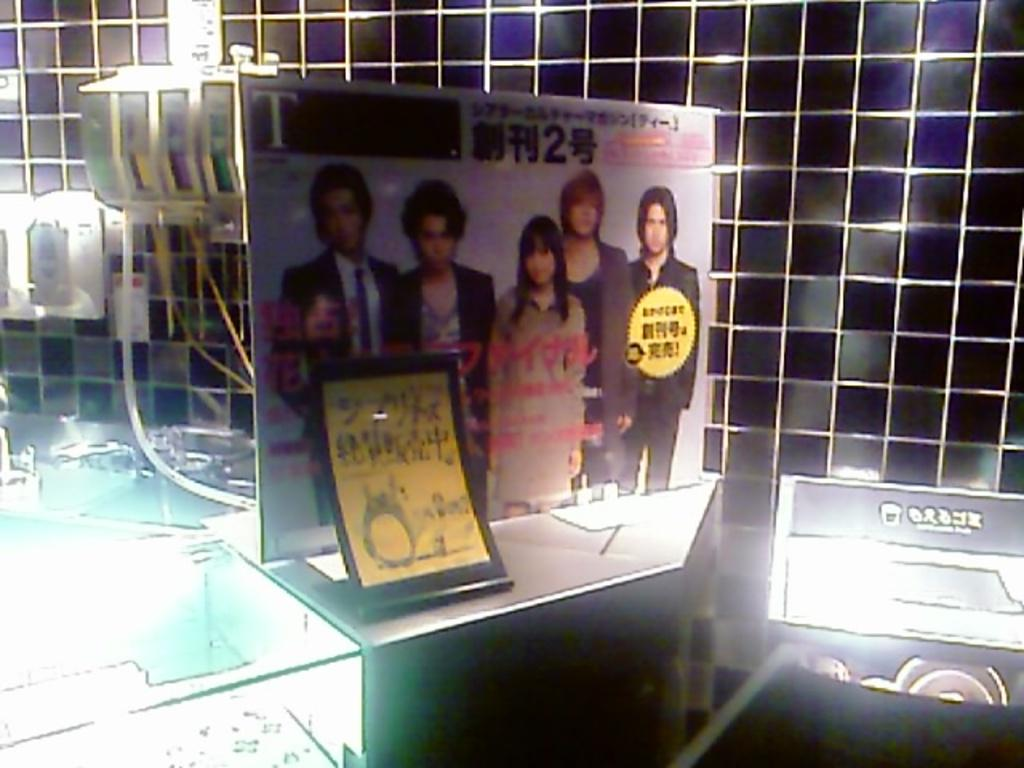What is the main subject of the image? There is a picture in the middle of the image. What else can be seen in the image besides the picture? Lights are visible in the image. What is located in the background of the image? There is a wall in the background of the image. Can you tell me how much rice is being cooked in the image? There is no rice present in the image, so it is not possible to determine how much rice might be being cooked. 